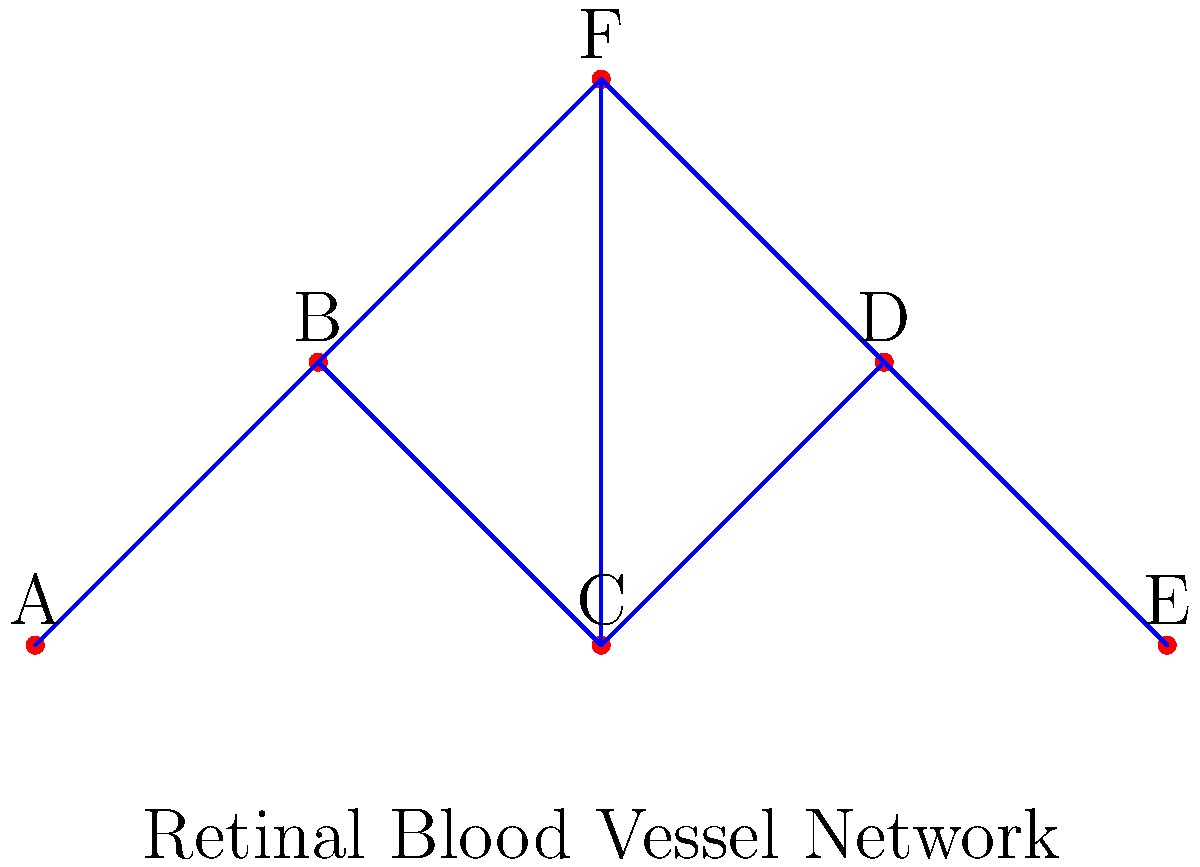In the retinal blood vessel network diagram above, which represents interconnected vessels in a patient with age-related macular degeneration (AMD), how many different paths exist to travel from point A to point E without revisiting any point? To solve this problem, we need to systematically count all possible paths from A to E without repeating any point. Let's break it down step-by-step:

1. Start at point A. We can only go to B from here.

2. From B, we have two options:
   a) Go directly to C
   b) Go to F

3. If we chose path a (B to C):
   - From C, we can go to D or F
   - If we go to D, we can only proceed to E (1 path)
   - If we go to F, we must then go to D and finally to E (1 path)

4. If we chose path b (B to F):
   - From F, we can go to C or D
   - If we go to C, we must then go to D and finally to E (1 path)
   - If we go to D, we can only proceed to E (1 path)

5. Counting all these paths:
   - A → B → C → D → E
   - A → B → C → F → D → E
   - A → B → F → C → D → E
   - A → B → F → D → E

Therefore, there are 4 different paths from A to E without revisiting any point.

This network topology is relevant to understanding the complexity of blood flow in the retina, which can be affected in AMD. The multiple pathways represent the redundancy in blood supply, which is crucial for maintaining retinal health.
Answer: 4 paths 